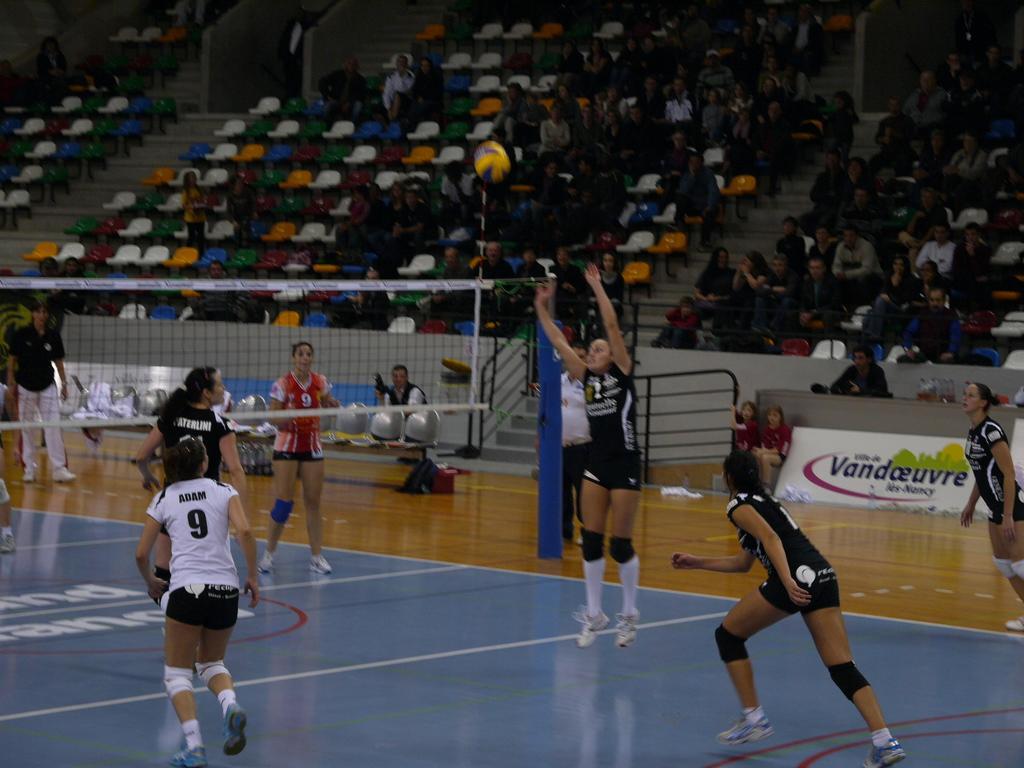How would you summarize this image in a sentence or two? This image is taken in a stadium. At the bottom of the image there is a floor. In the background there are many empty chairs and a few people are sitting on the chairs. There are a few stairs. On the left side of the image there is a net and a few people are standing on the floor. In the middle of the image six women are playing volleyball and there is a ball and a man is sitting on the chair. There is a board with a text on it and there is a railing. 